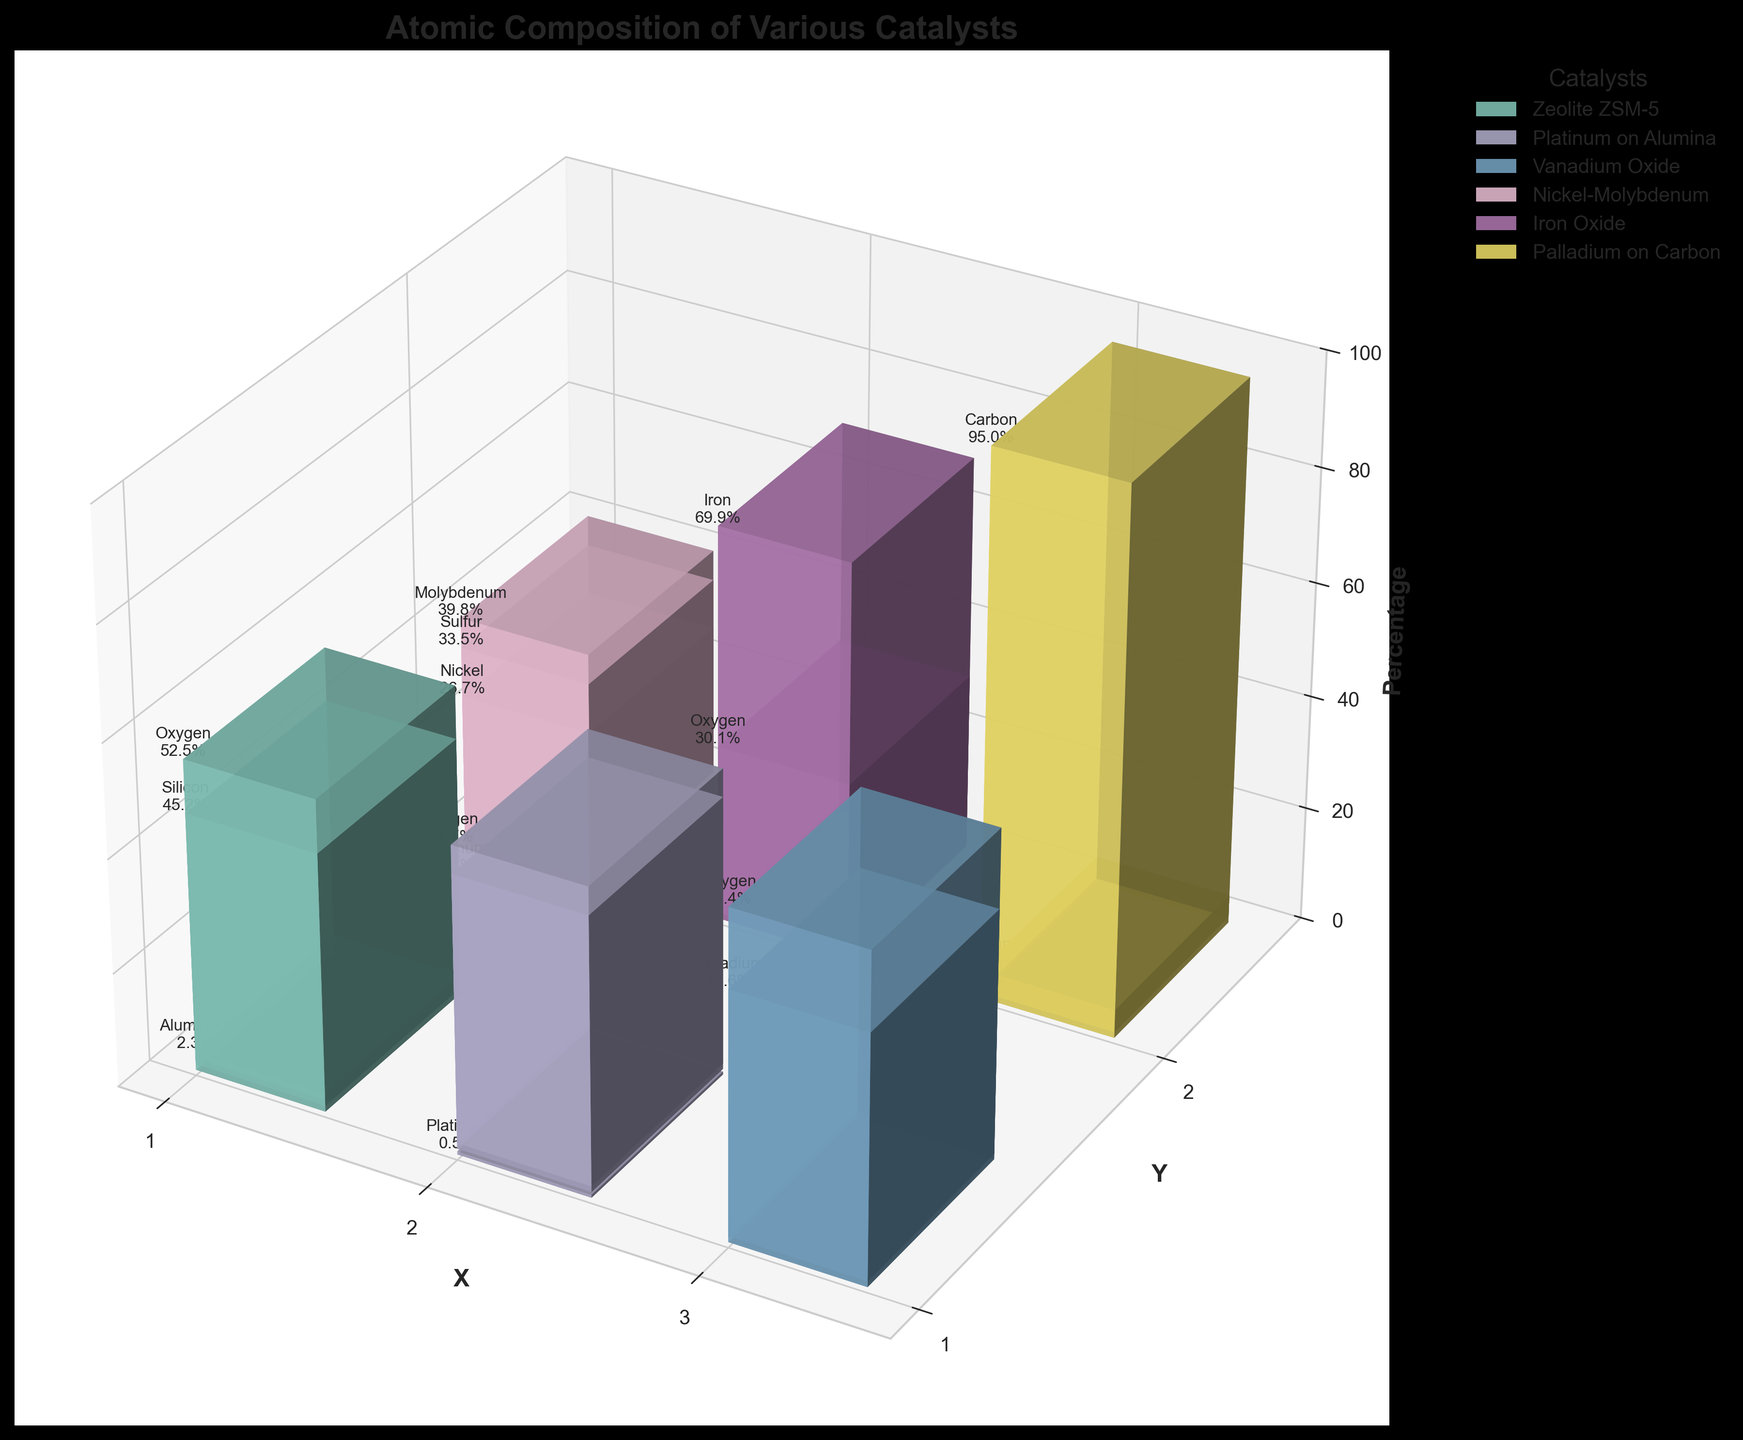What is the title of the figure? The title of the figure is displayed at the top of the plot, usually in larger font size and bold style to highlight what the visualization represents.
Answer: Atomic Composition of Various Catalysts Which element has the highest percentage in Zeolite ZSM-5? By examining the 3D bars for Zeolite ZSM-5 and the text labels indicating the percentages, find the element with the highest value.
Answer: Oxygen How many different catalysts are shown in the figure? The legend on the right side of the plot lists all unique catalysts, indicated by different colors. Count these entries.
Answer: 6 Which catalyst comprises only two elements? Look at the text labels on the 3D bars for each catalyst. The catalyst with only two different elements listed in the figure is the answer.
Answer: Vanadium Oxide For Nickel-Molybdenum, what is the sum of the percentages for Nickel and Sulfur? Locate the 3D bars for Nickel-Molybdenum and identify the bars for Nickel and Sulfur. Add their percentages together: 26.7 + 33.5.
Answer: 60.2 Which catalyst has the highest percentage of Oxygen? Compare the Oxygen percentages for each catalyst. The one with the highest percentage is the answer.
Answer: Zeolite ZSM-5 Is the percentage of Iron in Iron Oxide greater than that of Aluminum in Platinum on Alumina? Check the percentages of Iron in Iron Oxide and Aluminum in Platinum on Alumina from the 3D bars and text labels, then compare them: 69.9% vs. 47.8%.
Answer: Yes What are the percentages of elements in Vanadium Oxide? Locate the 3D bars for Vanadium Oxide and read the percentages for its elements.
Answer: Vanadium 43.6%, Oxygen 56.4% What is the average percentage of the elements in Palladium on Carbon? Locate the 3D bars for Palladium on Carbon and sum the percentages: 5.0 + 95.0 = 100.0. Since there are two elements, divide by 2 to get the average: 100.0 / 2.
Answer: 50.0 Which element in Platinum on Alumina has the smallest percentage? Check the text labels next to the 3D bars in Platinum on Alumina. Compare the percentages and identify the smallest one.
Answer: Platinum 